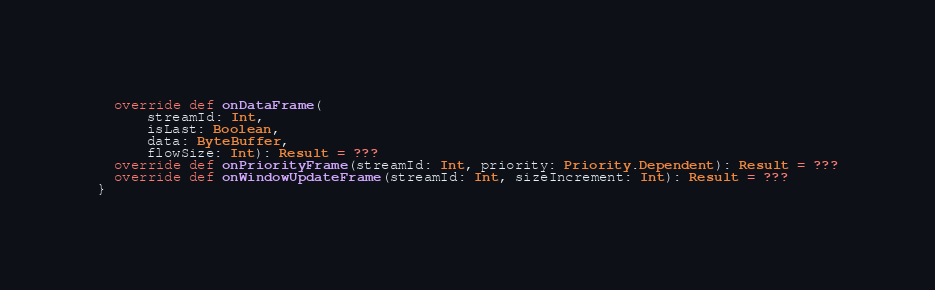Convert code to text. <code><loc_0><loc_0><loc_500><loc_500><_Scala_>  override def onDataFrame(
      streamId: Int,
      isLast: Boolean,
      data: ByteBuffer,
      flowSize: Int): Result = ???
  override def onPriorityFrame(streamId: Int, priority: Priority.Dependent): Result = ???
  override def onWindowUpdateFrame(streamId: Int, sizeIncrement: Int): Result = ???
}
</code> 